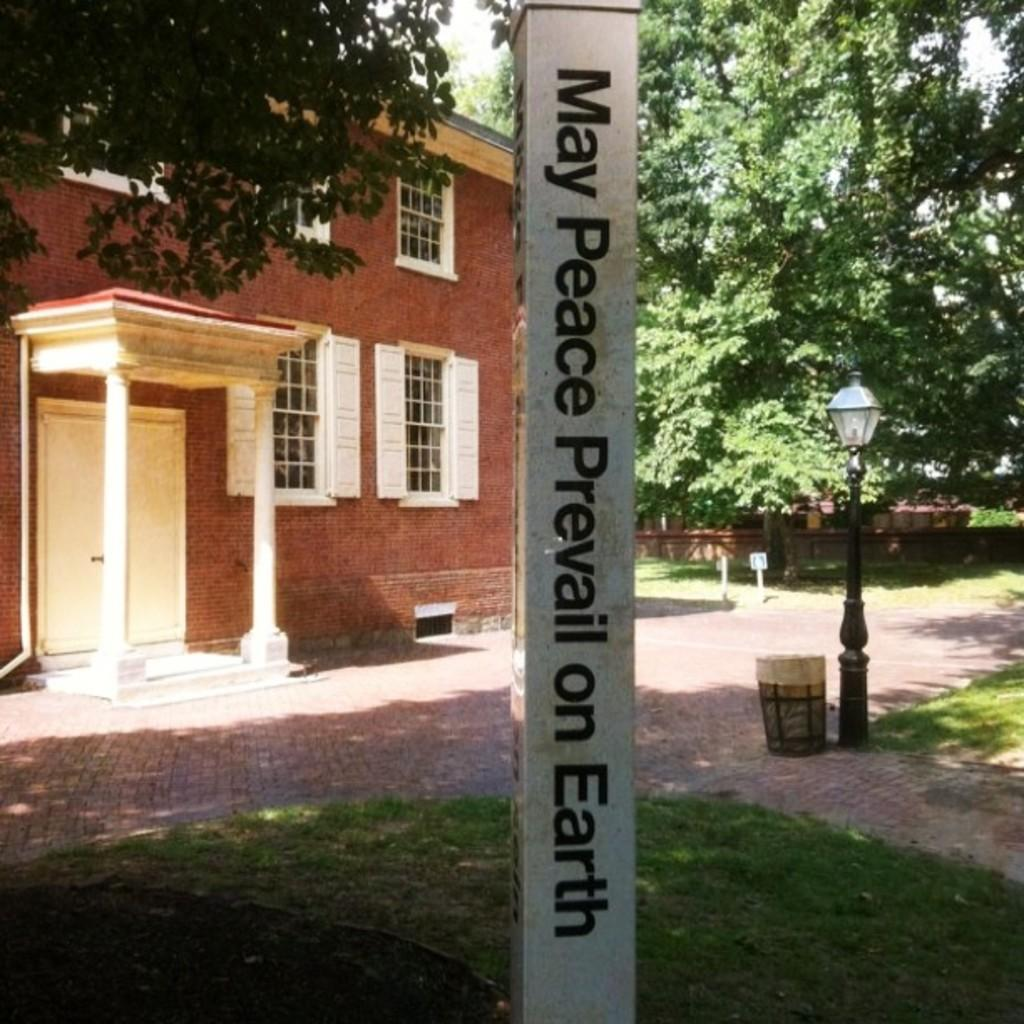What is written or displayed on the pole in the image? There are letters on a pole in the image. What type of structure can be seen in the image? There is a house in the image. What is the source of illumination in the image? There is a light in the image. What object is used for waste disposal in the image? There is a dustbin in the image. What type of vegetation is present in the image? There are trees in the image. Can you see any milk being delivered in the image? There is no milk or milk delivery visible in the image. Are there any bees buzzing around the trees in the image? There is no mention of bees or any insects in the image; only trees are mentioned. 